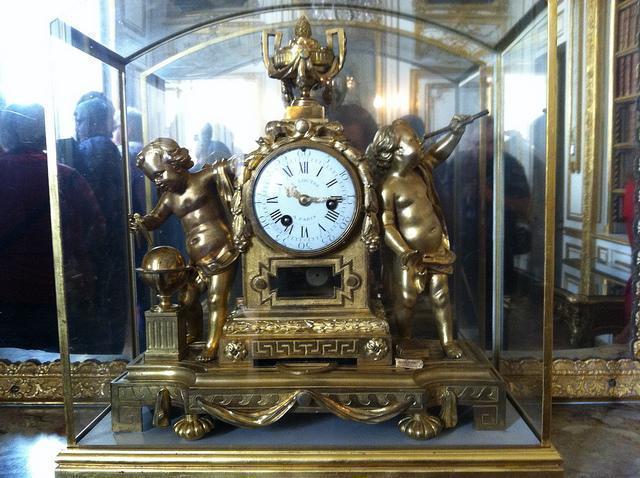What is located behind the clock?
Choose the right answer from the provided options to respond to the question.
Options: Large room, mirror, open museum, nothing. Mirror. 